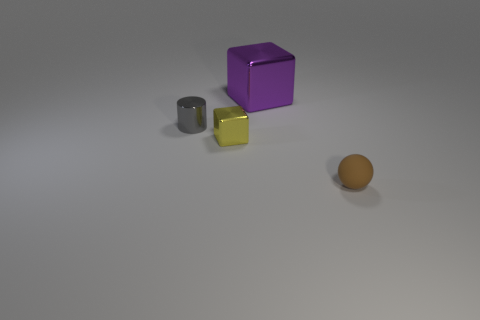Add 3 large gray rubber things. How many objects exist? 7 Subtract all spheres. How many objects are left? 3 Add 3 small gray shiny cylinders. How many small gray shiny cylinders are left? 4 Add 2 big purple matte blocks. How many big purple matte blocks exist? 2 Subtract 1 brown balls. How many objects are left? 3 Subtract all small yellow metallic objects. Subtract all small red matte cylinders. How many objects are left? 3 